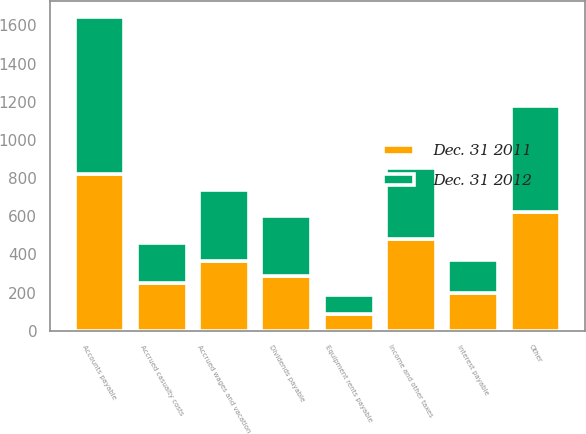Convert chart. <chart><loc_0><loc_0><loc_500><loc_500><stacked_bar_chart><ecel><fcel>Accounts payable<fcel>Accrued wages and vacation<fcel>Income and other taxes<fcel>Dividends payable<fcel>Accrued casualty costs<fcel>Interest payable<fcel>Equipment rents payable<fcel>Other<nl><fcel>Dec. 31 2012<fcel>825<fcel>376<fcel>368<fcel>318<fcel>213<fcel>172<fcel>95<fcel>556<nl><fcel>Dec. 31 2011<fcel>819<fcel>363<fcel>482<fcel>284<fcel>249<fcel>197<fcel>90<fcel>624<nl></chart> 